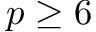Convert formula to latex. <formula><loc_0><loc_0><loc_500><loc_500>p \geq 6</formula> 